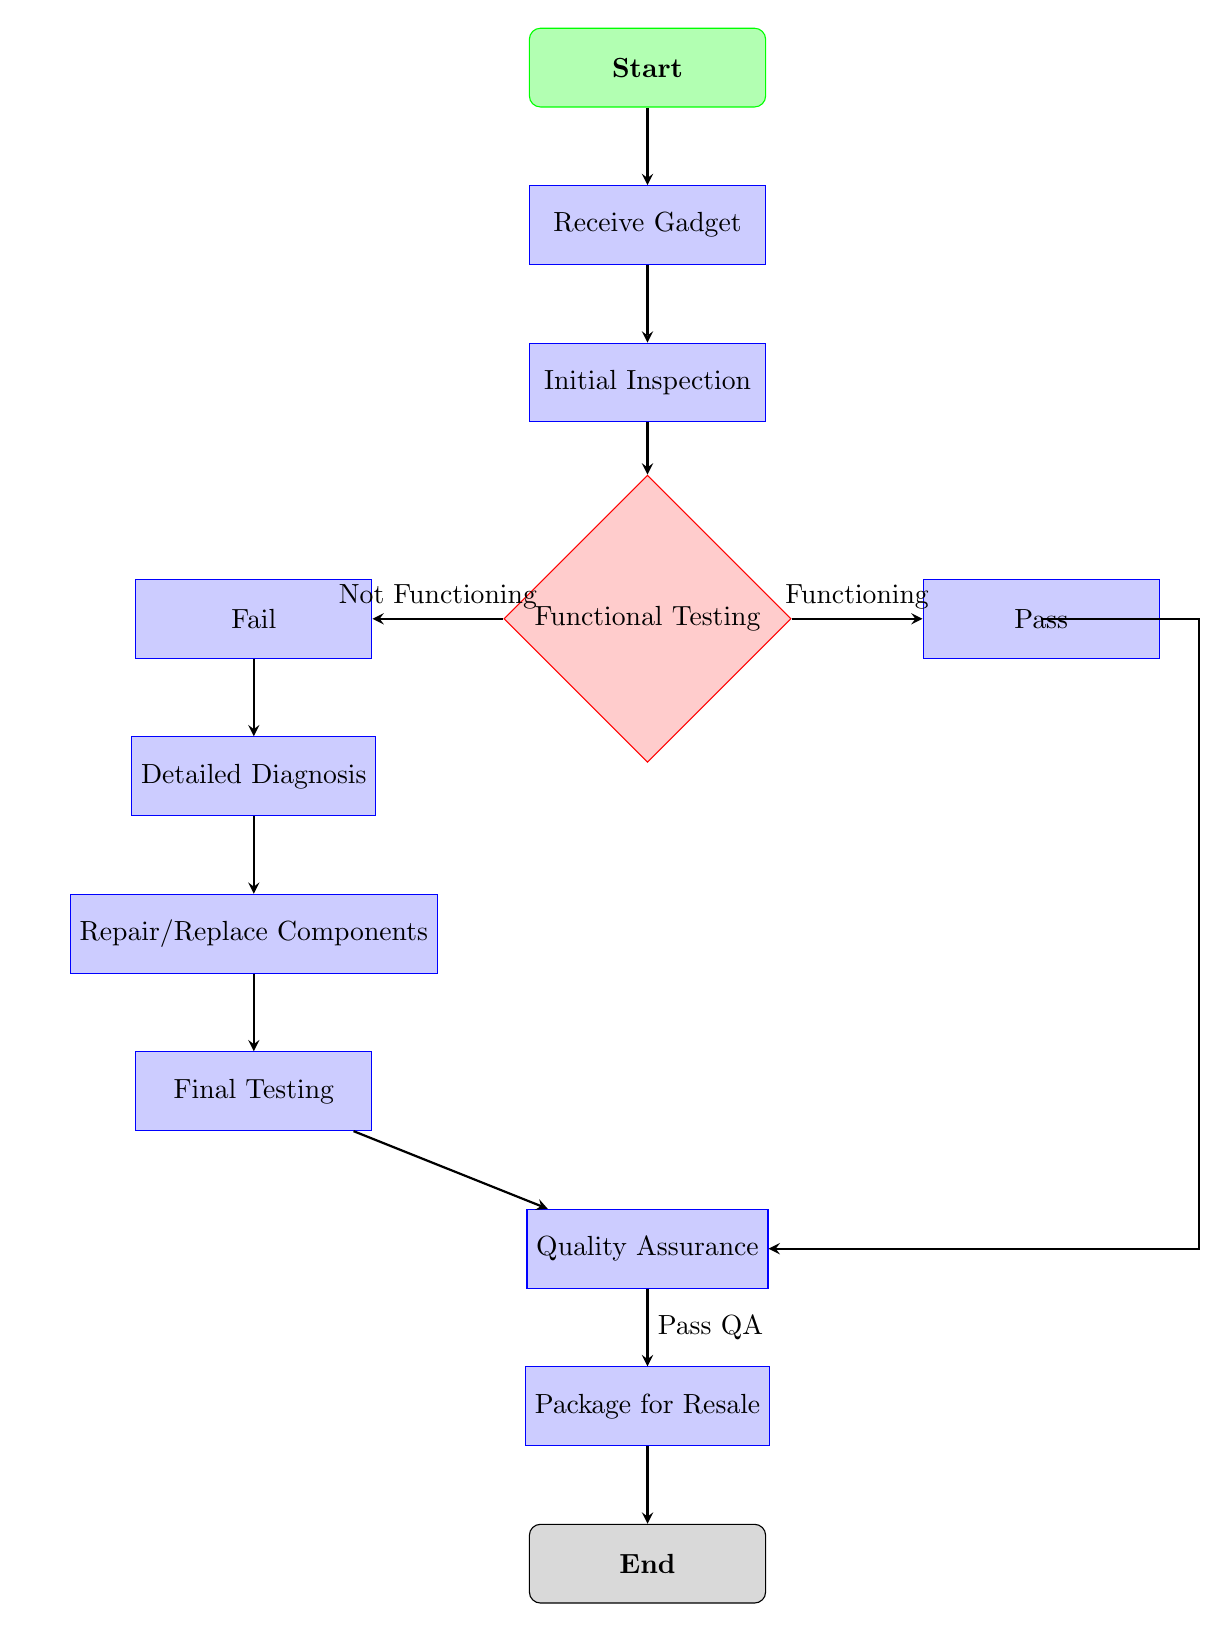What is the first step in the process? The first step in the process is represented by the 'Start' node at the top of the diagram.
Answer: Start How many main process nodes are there? The main process nodes are 'Receive Gadget', 'Initial Inspection', 'Detailed Diagnosis', 'Repair/Replace Components', 'Final Testing', 'Quality Assurance', and 'Package for Resale'. Counting these gives a total of 6 process nodes.
Answer: 6 What follows the 'Final Testing' step? After 'Final Testing', the next step in the process is 'Quality Assurance', which is indicated by the arrow leading from 'Final Testing'.
Answer: Quality Assurance What happens if the functional testing fails? If 'Functional Testing' fails, the process moves to 'Fail', as indicated by the arrow labeled 'Not Functioning'. From 'Fail', the next step is 'Detailed Diagnosis'.
Answer: Detailed Diagnosis Which node connects directly to 'Pass'? The 'Pass' node connects directly from the 'Functional Testing' decision node when the result is 'Functioning', as shown by the arrow going right.
Answer: Functional Testing What is the final outcome of the diagnostic process? The final outcome of the diagnostic process is 'End', which is the last node in the flowchart, and all paths eventually lead to this node.
Answer: End If a gadget passes QA, what is the next step? If a gadget passes QA, it moves to 'Package for Resale', according to the arrow leading from 'Quality Assurance' labeled 'Pass QA'.
Answer: Package for Resale How many decision points are there in the flowchart? There is one decision point in the flowchart, which is 'Functional Testing', indicated by the diamond shape that distinguishes it from process nodes.
Answer: 1 What type of shape is used for the 'Repair/Replace Components' node? The 'Repair/Replace Components' node is a rectangle, as indicated by its shape in the diagram, which represents a process.
Answer: Rectangle 